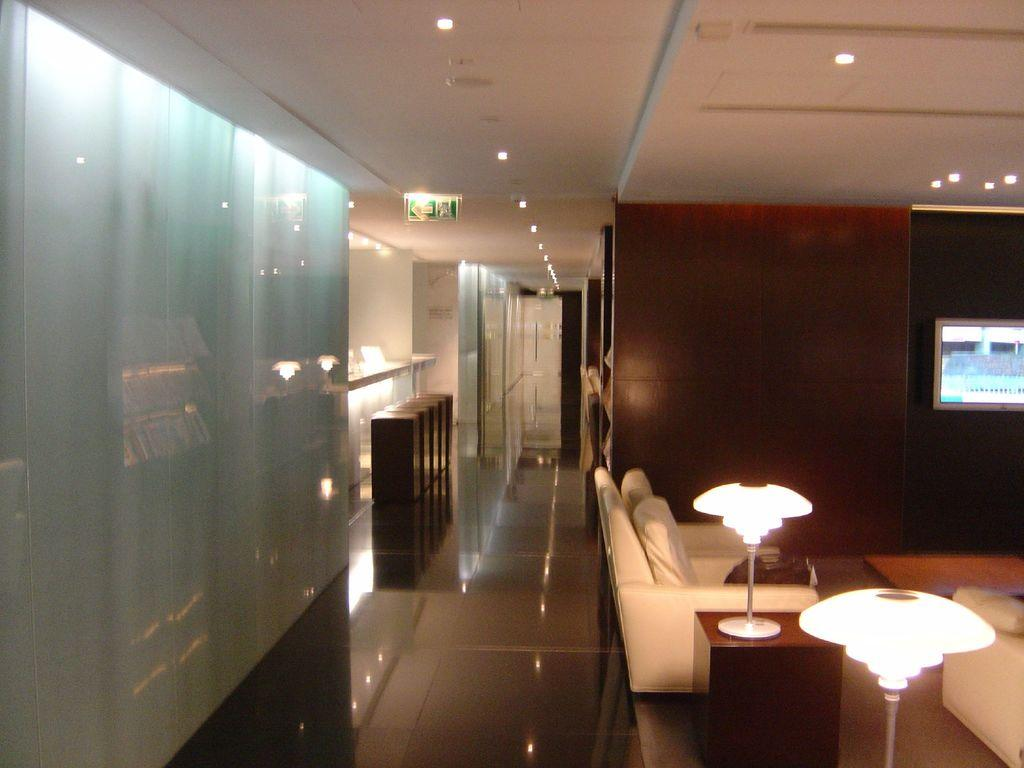What type of furniture can be seen in the image? There are chairs in the image. What is located beside the chair? There is a table beside the chair. What is on the table? A lamp is present on the table. What is attached to the roof in the image? Lights are attached to the roof. What material is used for some of the objects in the image? There are wooden objects in the image. Where is the TV located in the image? A TV is attached to the wall. Can you tell me how many people are smiling in the image? There are no people present in the image, so it is not possible to determine how many people are smiling. What type of pot can be seen on the table in the image? There is no pot present on the table in the image; only a lamp is visible. 